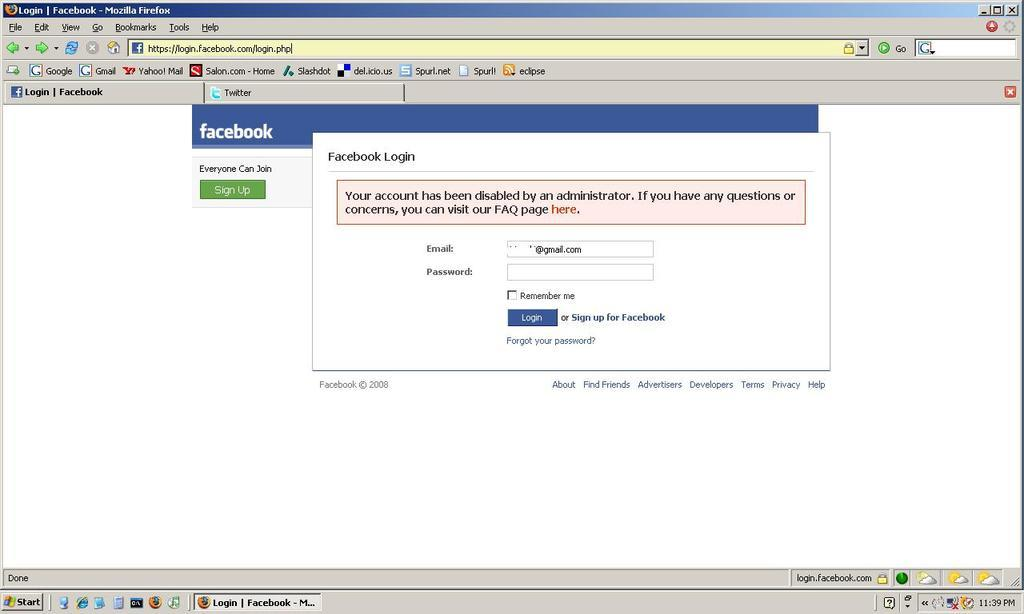<image>
Summarize the visual content of the image. a firefox web browser open to the facebook login page 